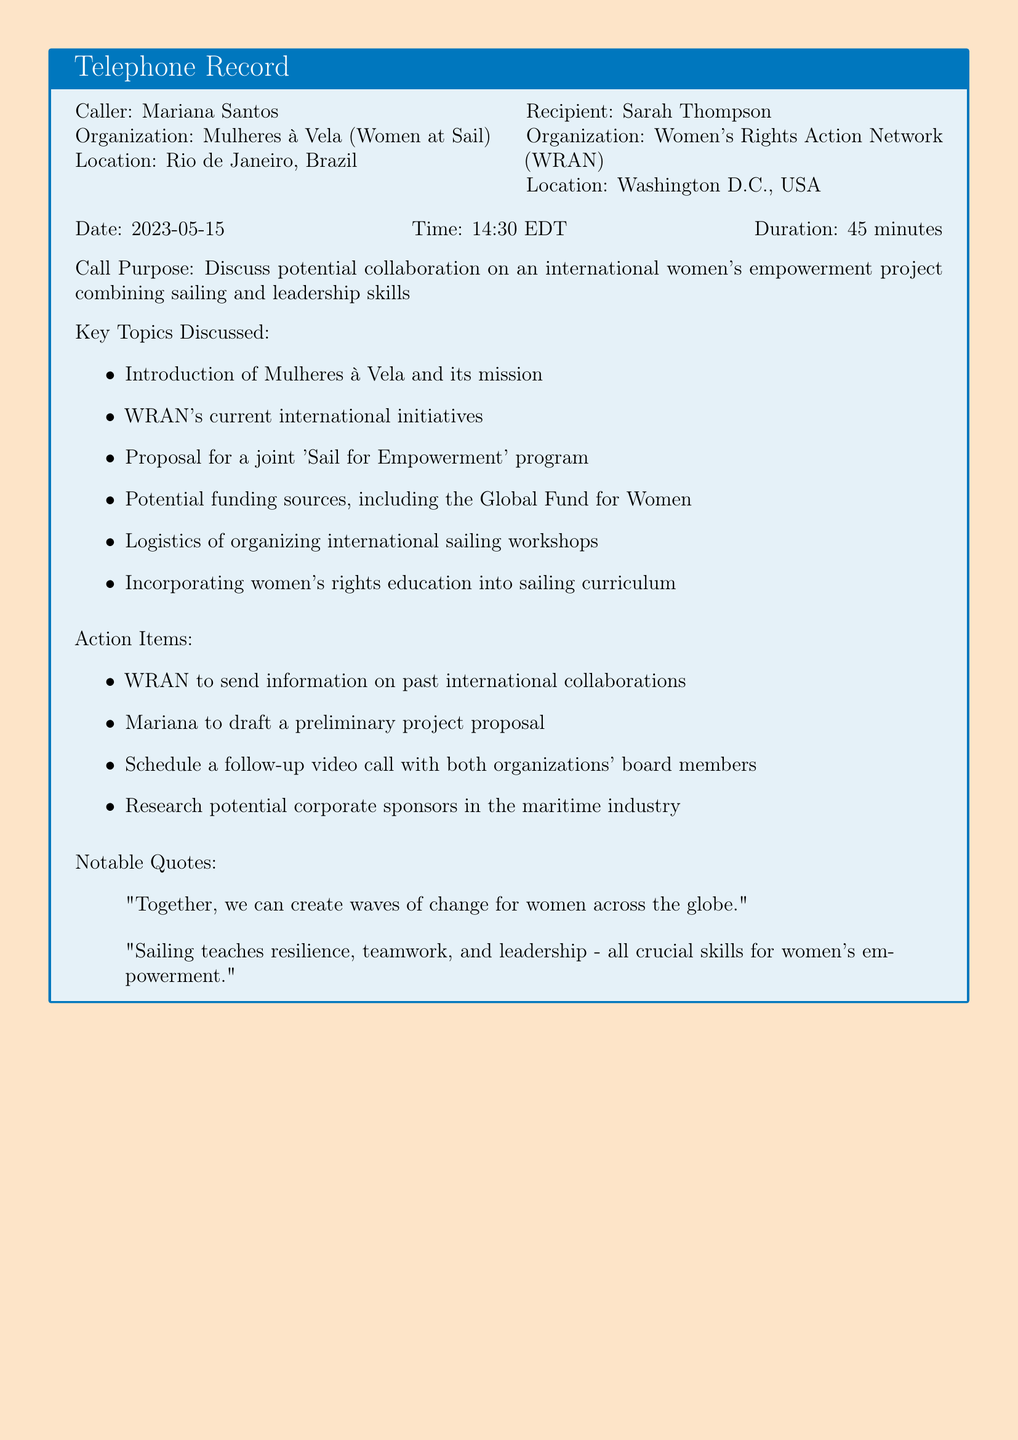What is the name of the caller? The caller's name is explicitly stated in the document.
Answer: Mariana Santos What is the organization of the recipient? The organization for the recipient is provided in the document under their details.
Answer: Women's Rights Action Network (WRAN) What is the date of the call? The date is listed in the document as part of the call details.
Answer: 2023-05-15 What was the duration of the call? The duration is included in the call details section of the document.
Answer: 45 minutes What is one key topic discussed during the call? The document lists several key topics discussed during the call.
Answer: Proposal for a joint 'Sail for Empowerment' program Who is responsible for drafting a preliminary project proposal? The action item indicates who will be drafting the proposal based on the discussion.
Answer: Mariana What notable quote mentions creating change for women? A notable quote is recorded in the document that emphasizes change for women.
Answer: "Together, we can create waves of change for women across the globe." What is the primary purpose of the call? The primary purpose is clearly stated in the document.
Answer: Discuss potential collaboration on an international women's empowerment project combining sailing and leadership skills 